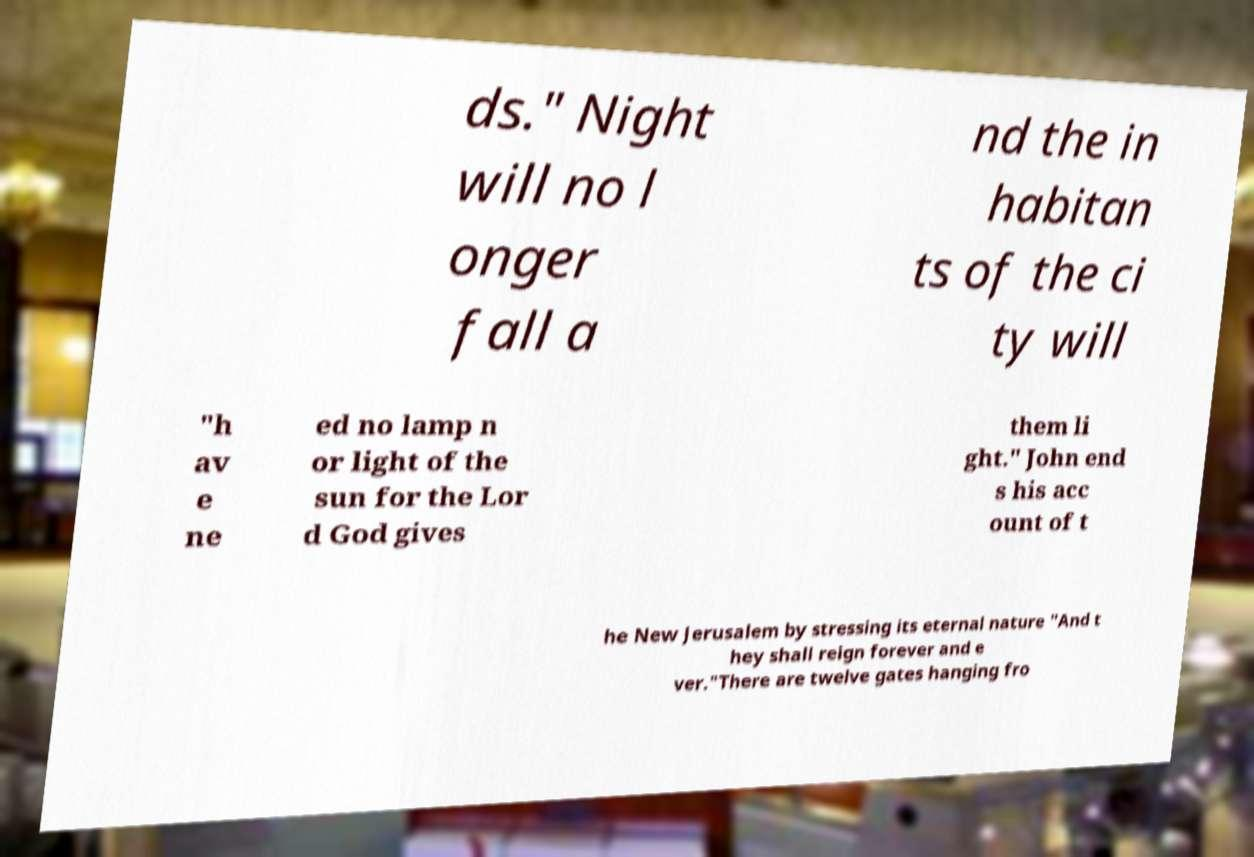There's text embedded in this image that I need extracted. Can you transcribe it verbatim? ds." Night will no l onger fall a nd the in habitan ts of the ci ty will "h av e ne ed no lamp n or light of the sun for the Lor d God gives them li ght." John end s his acc ount of t he New Jerusalem by stressing its eternal nature "And t hey shall reign forever and e ver."There are twelve gates hanging fro 